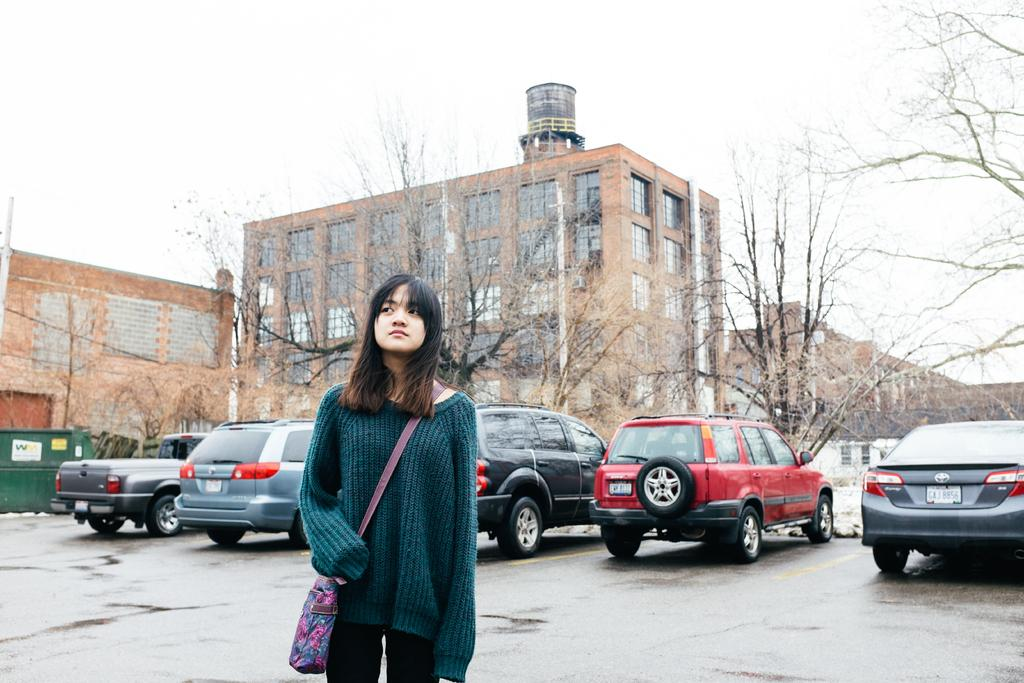Who or what is the main subject in the image? There is a person in the image. What is the person wearing that is visible in the image? The person is wearing a sling bag. What can be seen in the background of the image? There are buildings, trees, walls, windows, vehicles, and the sky visible in the background of the image. What type of calculator is the person using in the image? There is no calculator present in the image. What sense is the person experiencing while standing in the image? The image does not provide information about the person's senses or experiences. 